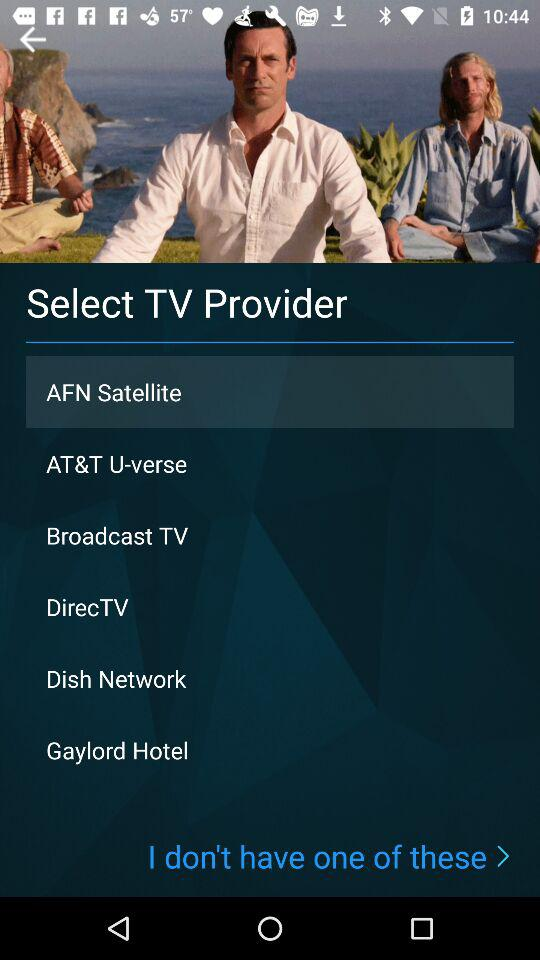Which TV provider was selected? The selected TV provider was "AFN Satellite". 